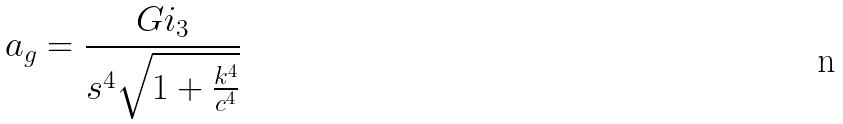Convert formula to latex. <formula><loc_0><loc_0><loc_500><loc_500>a _ { g } = \frac { G i _ { 3 } } { s ^ { 4 } \sqrt { 1 + \frac { k ^ { 4 } } { c ^ { 4 } } } }</formula> 